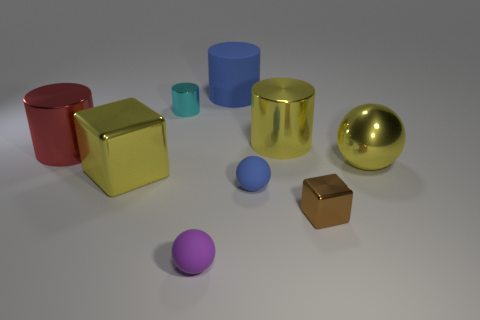Subtract all small metallic cylinders. How many cylinders are left? 3 Add 1 brown metal objects. How many objects exist? 10 Subtract all yellow spheres. How many spheres are left? 2 Subtract 2 cubes. How many cubes are left? 0 Subtract all green blocks. Subtract all green spheres. How many blocks are left? 2 Subtract all yellow balls. How many brown cubes are left? 1 Subtract all blue objects. Subtract all big red metal cylinders. How many objects are left? 6 Add 9 brown cubes. How many brown cubes are left? 10 Add 4 large green balls. How many large green balls exist? 4 Subtract 0 blue cubes. How many objects are left? 9 